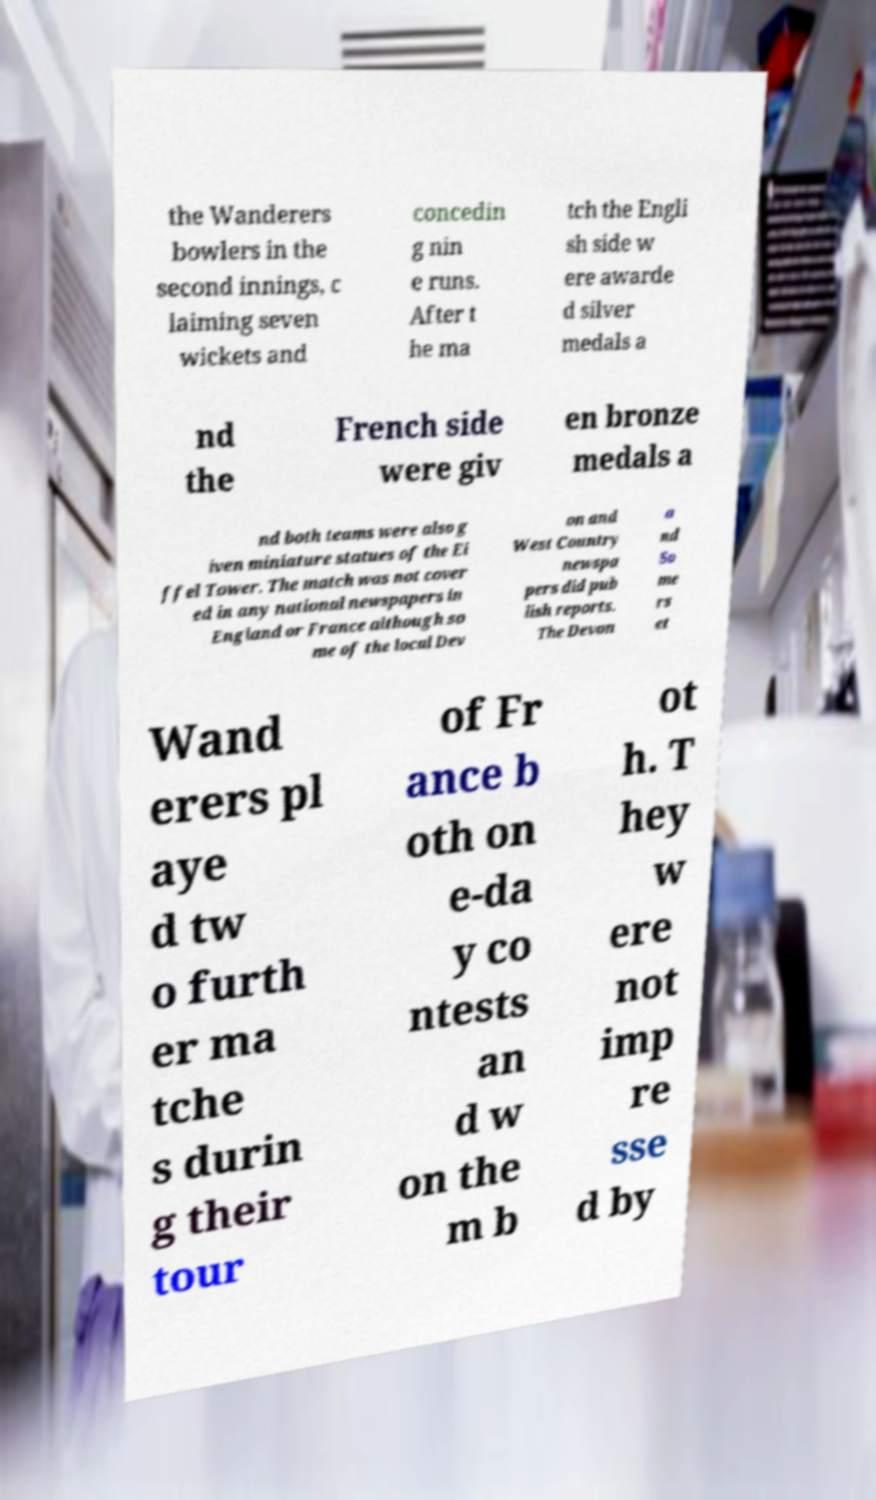There's text embedded in this image that I need extracted. Can you transcribe it verbatim? the Wanderers bowlers in the second innings, c laiming seven wickets and concedin g nin e runs. After t he ma tch the Engli sh side w ere awarde d silver medals a nd the French side were giv en bronze medals a nd both teams were also g iven miniature statues of the Ei ffel Tower. The match was not cover ed in any national newspapers in England or France although so me of the local Dev on and West Country newspa pers did pub lish reports. The Devon a nd So me rs et Wand erers pl aye d tw o furth er ma tche s durin g their tour of Fr ance b oth on e-da y co ntests an d w on the m b ot h. T hey w ere not imp re sse d by 